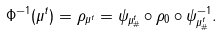<formula> <loc_0><loc_0><loc_500><loc_500>\Phi ^ { - 1 } ( \mu ^ { t } ) = \rho _ { \mu ^ { t } } = \psi _ { \mu ^ { t } _ { \# } } \circ \rho _ { 0 } \circ \psi _ { \mu ^ { t } _ { \# } } ^ { - 1 } .</formula> 